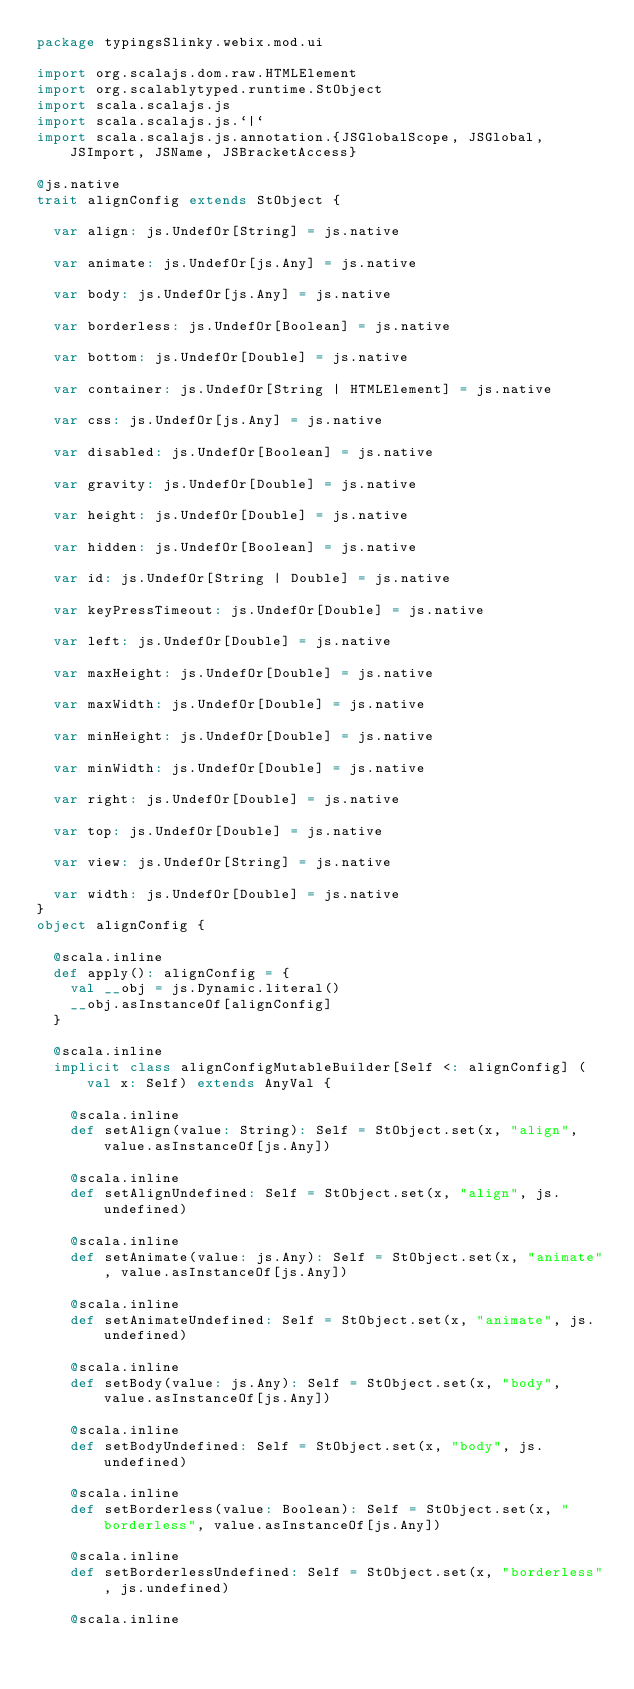Convert code to text. <code><loc_0><loc_0><loc_500><loc_500><_Scala_>package typingsSlinky.webix.mod.ui

import org.scalajs.dom.raw.HTMLElement
import org.scalablytyped.runtime.StObject
import scala.scalajs.js
import scala.scalajs.js.`|`
import scala.scalajs.js.annotation.{JSGlobalScope, JSGlobal, JSImport, JSName, JSBracketAccess}

@js.native
trait alignConfig extends StObject {
  
  var align: js.UndefOr[String] = js.native
  
  var animate: js.UndefOr[js.Any] = js.native
  
  var body: js.UndefOr[js.Any] = js.native
  
  var borderless: js.UndefOr[Boolean] = js.native
  
  var bottom: js.UndefOr[Double] = js.native
  
  var container: js.UndefOr[String | HTMLElement] = js.native
  
  var css: js.UndefOr[js.Any] = js.native
  
  var disabled: js.UndefOr[Boolean] = js.native
  
  var gravity: js.UndefOr[Double] = js.native
  
  var height: js.UndefOr[Double] = js.native
  
  var hidden: js.UndefOr[Boolean] = js.native
  
  var id: js.UndefOr[String | Double] = js.native
  
  var keyPressTimeout: js.UndefOr[Double] = js.native
  
  var left: js.UndefOr[Double] = js.native
  
  var maxHeight: js.UndefOr[Double] = js.native
  
  var maxWidth: js.UndefOr[Double] = js.native
  
  var minHeight: js.UndefOr[Double] = js.native
  
  var minWidth: js.UndefOr[Double] = js.native
  
  var right: js.UndefOr[Double] = js.native
  
  var top: js.UndefOr[Double] = js.native
  
  var view: js.UndefOr[String] = js.native
  
  var width: js.UndefOr[Double] = js.native
}
object alignConfig {
  
  @scala.inline
  def apply(): alignConfig = {
    val __obj = js.Dynamic.literal()
    __obj.asInstanceOf[alignConfig]
  }
  
  @scala.inline
  implicit class alignConfigMutableBuilder[Self <: alignConfig] (val x: Self) extends AnyVal {
    
    @scala.inline
    def setAlign(value: String): Self = StObject.set(x, "align", value.asInstanceOf[js.Any])
    
    @scala.inline
    def setAlignUndefined: Self = StObject.set(x, "align", js.undefined)
    
    @scala.inline
    def setAnimate(value: js.Any): Self = StObject.set(x, "animate", value.asInstanceOf[js.Any])
    
    @scala.inline
    def setAnimateUndefined: Self = StObject.set(x, "animate", js.undefined)
    
    @scala.inline
    def setBody(value: js.Any): Self = StObject.set(x, "body", value.asInstanceOf[js.Any])
    
    @scala.inline
    def setBodyUndefined: Self = StObject.set(x, "body", js.undefined)
    
    @scala.inline
    def setBorderless(value: Boolean): Self = StObject.set(x, "borderless", value.asInstanceOf[js.Any])
    
    @scala.inline
    def setBorderlessUndefined: Self = StObject.set(x, "borderless", js.undefined)
    
    @scala.inline</code> 